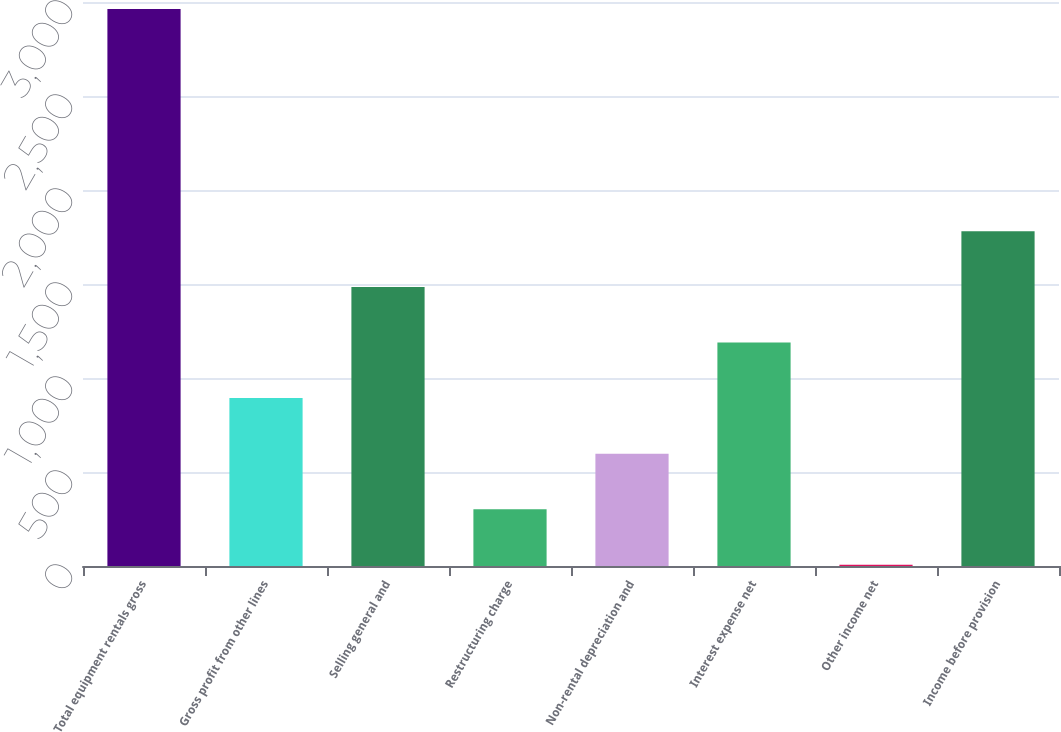Convert chart to OTSL. <chart><loc_0><loc_0><loc_500><loc_500><bar_chart><fcel>Total equipment rentals gross<fcel>Gross profit from other lines<fcel>Selling general and<fcel>Restructuring charge<fcel>Non-rental depreciation and<fcel>Interest expense net<fcel>Other income net<fcel>Income before provision<nl><fcel>2963<fcel>893.1<fcel>1484.5<fcel>301.7<fcel>597.4<fcel>1188.8<fcel>6<fcel>1780.2<nl></chart> 